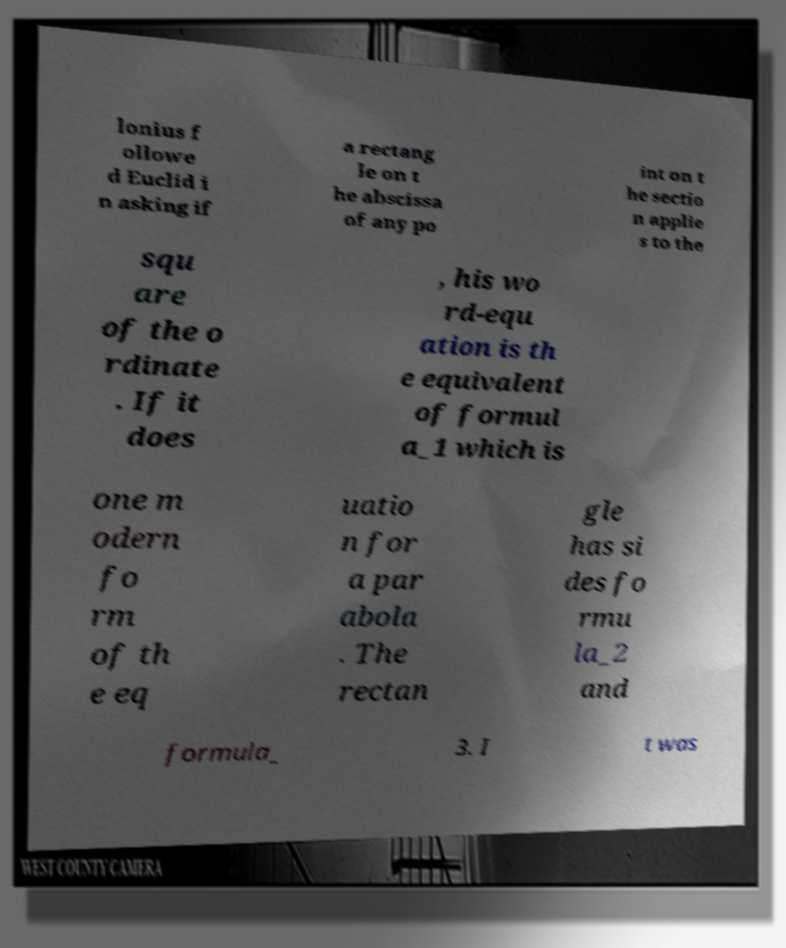Please identify and transcribe the text found in this image. lonius f ollowe d Euclid i n asking if a rectang le on t he abscissa of any po int on t he sectio n applie s to the squ are of the o rdinate . If it does , his wo rd-equ ation is th e equivalent of formul a_1 which is one m odern fo rm of th e eq uatio n for a par abola . The rectan gle has si des fo rmu la_2 and formula_ 3. I t was 